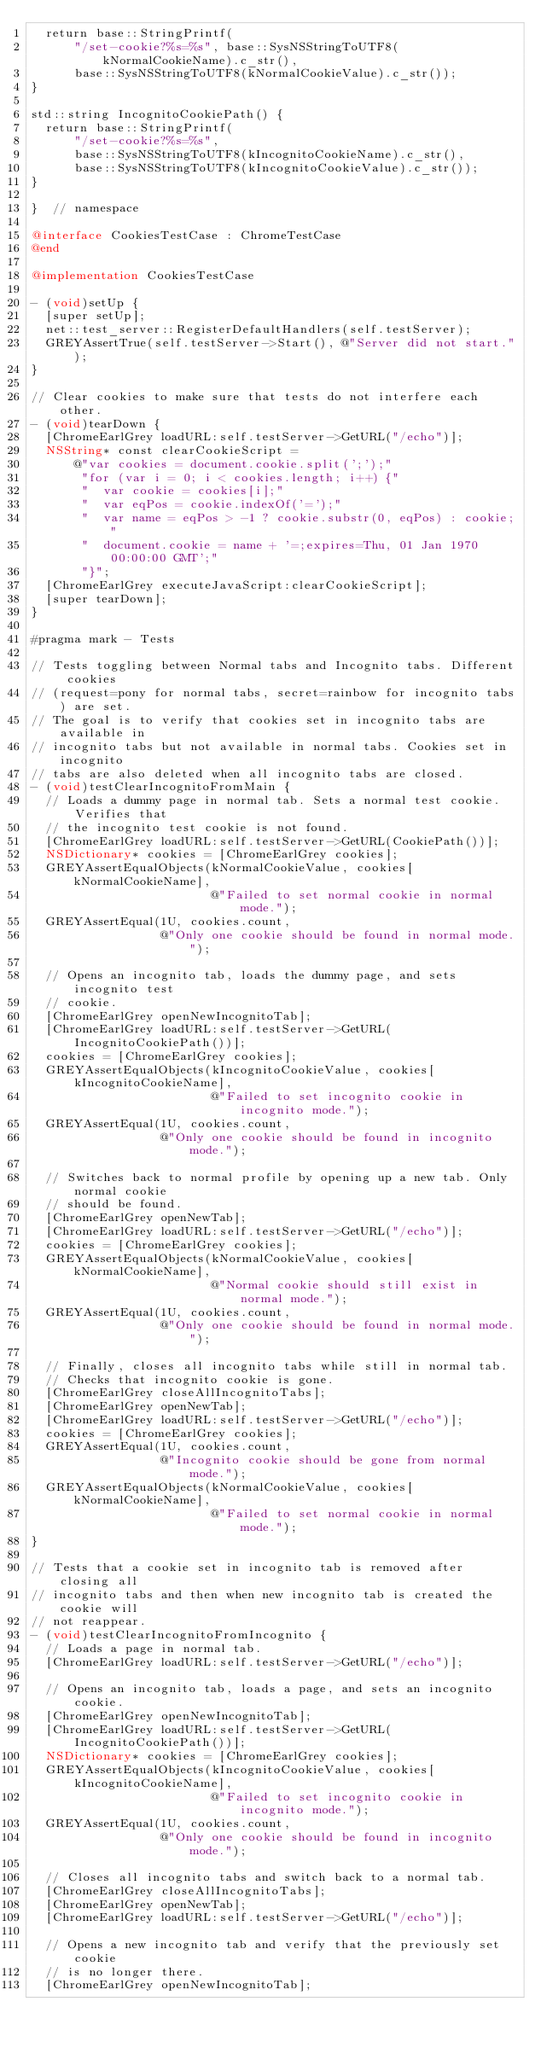Convert code to text. <code><loc_0><loc_0><loc_500><loc_500><_ObjectiveC_>  return base::StringPrintf(
      "/set-cookie?%s=%s", base::SysNSStringToUTF8(kNormalCookieName).c_str(),
      base::SysNSStringToUTF8(kNormalCookieValue).c_str());
}

std::string IncognitoCookiePath() {
  return base::StringPrintf(
      "/set-cookie?%s=%s",
      base::SysNSStringToUTF8(kIncognitoCookieName).c_str(),
      base::SysNSStringToUTF8(kIncognitoCookieValue).c_str());
}

}  // namespace

@interface CookiesTestCase : ChromeTestCase
@end

@implementation CookiesTestCase

- (void)setUp {
  [super setUp];
  net::test_server::RegisterDefaultHandlers(self.testServer);
  GREYAssertTrue(self.testServer->Start(), @"Server did not start.");
}

// Clear cookies to make sure that tests do not interfere each other.
- (void)tearDown {
  [ChromeEarlGrey loadURL:self.testServer->GetURL("/echo")];
  NSString* const clearCookieScript =
      @"var cookies = document.cookie.split(';');"
       "for (var i = 0; i < cookies.length; i++) {"
       "  var cookie = cookies[i];"
       "  var eqPos = cookie.indexOf('=');"
       "  var name = eqPos > -1 ? cookie.substr(0, eqPos) : cookie;"
       "  document.cookie = name + '=;expires=Thu, 01 Jan 1970 00:00:00 GMT';"
       "}";
  [ChromeEarlGrey executeJavaScript:clearCookieScript];
  [super tearDown];
}

#pragma mark - Tests

// Tests toggling between Normal tabs and Incognito tabs. Different cookies
// (request=pony for normal tabs, secret=rainbow for incognito tabs) are set.
// The goal is to verify that cookies set in incognito tabs are available in
// incognito tabs but not available in normal tabs. Cookies set in incognito
// tabs are also deleted when all incognito tabs are closed.
- (void)testClearIncognitoFromMain {
  // Loads a dummy page in normal tab. Sets a normal test cookie. Verifies that
  // the incognito test cookie is not found.
  [ChromeEarlGrey loadURL:self.testServer->GetURL(CookiePath())];
  NSDictionary* cookies = [ChromeEarlGrey cookies];
  GREYAssertEqualObjects(kNormalCookieValue, cookies[kNormalCookieName],
                         @"Failed to set normal cookie in normal mode.");
  GREYAssertEqual(1U, cookies.count,
                  @"Only one cookie should be found in normal mode.");

  // Opens an incognito tab, loads the dummy page, and sets incognito test
  // cookie.
  [ChromeEarlGrey openNewIncognitoTab];
  [ChromeEarlGrey loadURL:self.testServer->GetURL(IncognitoCookiePath())];
  cookies = [ChromeEarlGrey cookies];
  GREYAssertEqualObjects(kIncognitoCookieValue, cookies[kIncognitoCookieName],
                         @"Failed to set incognito cookie in incognito mode.");
  GREYAssertEqual(1U, cookies.count,
                  @"Only one cookie should be found in incognito mode.");

  // Switches back to normal profile by opening up a new tab. Only normal cookie
  // should be found.
  [ChromeEarlGrey openNewTab];
  [ChromeEarlGrey loadURL:self.testServer->GetURL("/echo")];
  cookies = [ChromeEarlGrey cookies];
  GREYAssertEqualObjects(kNormalCookieValue, cookies[kNormalCookieName],
                         @"Normal cookie should still exist in normal mode.");
  GREYAssertEqual(1U, cookies.count,
                  @"Only one cookie should be found in normal mode.");

  // Finally, closes all incognito tabs while still in normal tab.
  // Checks that incognito cookie is gone.
  [ChromeEarlGrey closeAllIncognitoTabs];
  [ChromeEarlGrey openNewTab];
  [ChromeEarlGrey loadURL:self.testServer->GetURL("/echo")];
  cookies = [ChromeEarlGrey cookies];
  GREYAssertEqual(1U, cookies.count,
                  @"Incognito cookie should be gone from normal mode.");
  GREYAssertEqualObjects(kNormalCookieValue, cookies[kNormalCookieName],
                         @"Failed to set normal cookie in normal mode.");
}

// Tests that a cookie set in incognito tab is removed after closing all
// incognito tabs and then when new incognito tab is created the cookie will
// not reappear.
- (void)testClearIncognitoFromIncognito {
  // Loads a page in normal tab.
  [ChromeEarlGrey loadURL:self.testServer->GetURL("/echo")];

  // Opens an incognito tab, loads a page, and sets an incognito cookie.
  [ChromeEarlGrey openNewIncognitoTab];
  [ChromeEarlGrey loadURL:self.testServer->GetURL(IncognitoCookiePath())];
  NSDictionary* cookies = [ChromeEarlGrey cookies];
  GREYAssertEqualObjects(kIncognitoCookieValue, cookies[kIncognitoCookieName],
                         @"Failed to set incognito cookie in incognito mode.");
  GREYAssertEqual(1U, cookies.count,
                  @"Only one cookie should be found in incognito mode.");

  // Closes all incognito tabs and switch back to a normal tab.
  [ChromeEarlGrey closeAllIncognitoTabs];
  [ChromeEarlGrey openNewTab];
  [ChromeEarlGrey loadURL:self.testServer->GetURL("/echo")];

  // Opens a new incognito tab and verify that the previously set cookie
  // is no longer there.
  [ChromeEarlGrey openNewIncognitoTab];</code> 